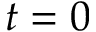Convert formula to latex. <formula><loc_0><loc_0><loc_500><loc_500>t = 0</formula> 